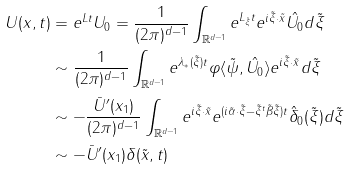<formula> <loc_0><loc_0><loc_500><loc_500>U ( x , t ) & = e ^ { L t } U _ { 0 } = \frac { 1 } { ( 2 \pi ) ^ { d - 1 } } \int _ { \mathbb { R } ^ { d - 1 } } e ^ { L _ { \tilde { \xi } } t } e ^ { i \tilde { \xi } \cdot \tilde { x } } \hat { U _ { 0 } } d \tilde { \xi } \\ & \sim \frac { 1 } { ( 2 \pi ) ^ { d - 1 } } \int _ { \mathbb { R } ^ { d - 1 } } e ^ { \lambda _ { * } ( \tilde { \xi } ) t } \varphi \langle \tilde { \psi } , \hat { U _ { 0 } } \rangle e ^ { i \tilde { \xi } \cdot \tilde { x } } d \tilde { \xi } \\ & \sim - \frac { \bar { U } ^ { \prime } ( x _ { 1 } ) } { ( 2 \pi ) ^ { d - 1 } } \int _ { \mathbb { R } ^ { d - 1 } } e ^ { i \tilde { \xi } \cdot \tilde { x } } e ^ { ( i \tilde { \alpha } \cdot \tilde { \xi } - \tilde { \xi } ^ { t } \tilde { \beta } \tilde { \xi } ) t } \hat { \delta } _ { 0 } ( \tilde { \xi } ) d \tilde { \xi } \\ & \sim - \bar { U } ^ { \prime } ( x _ { 1 } ) \delta ( \tilde { x } , t )</formula> 